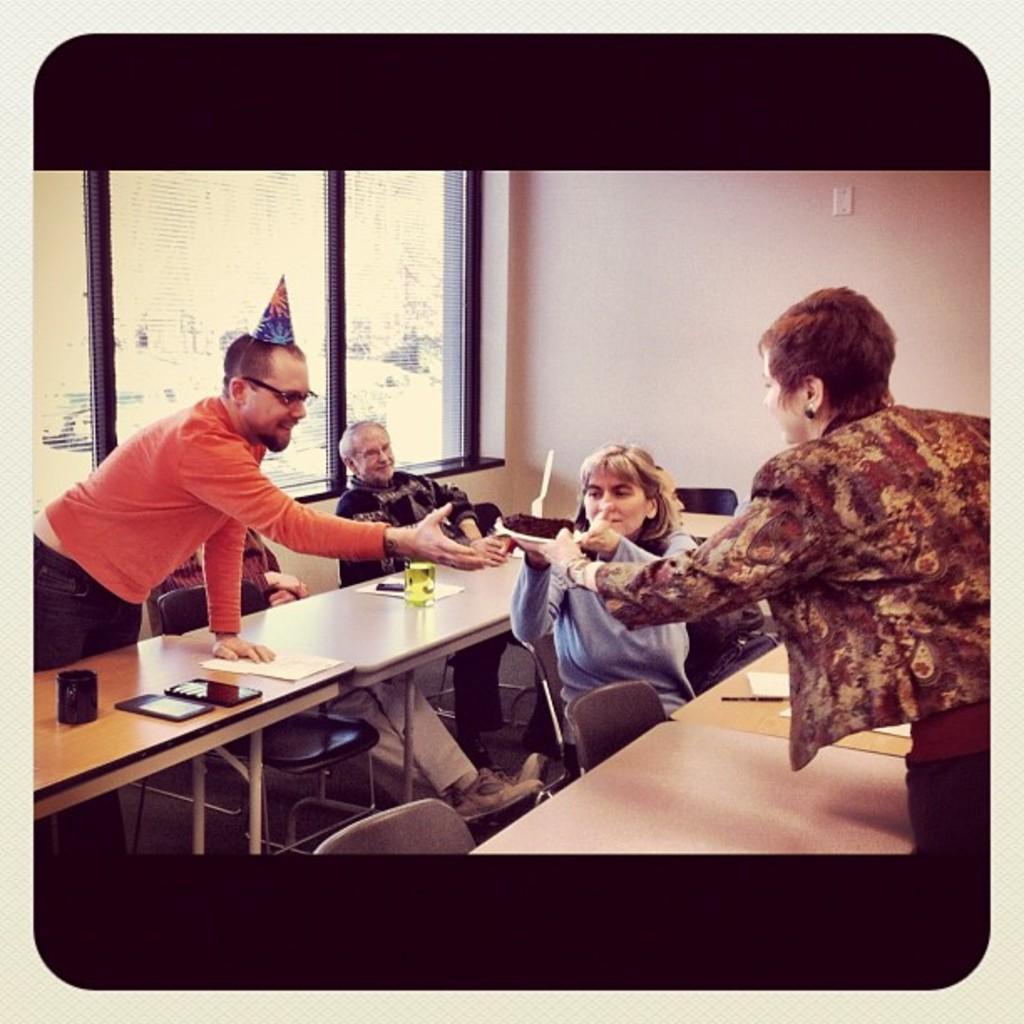In one or two sentences, can you explain what this image depicts? In this image we can see this people are sitting on the chairs near the table. We can see this persons are standing and passing a plate. We can see papers and mobile phones on the table. In the background we can see glass windows. 